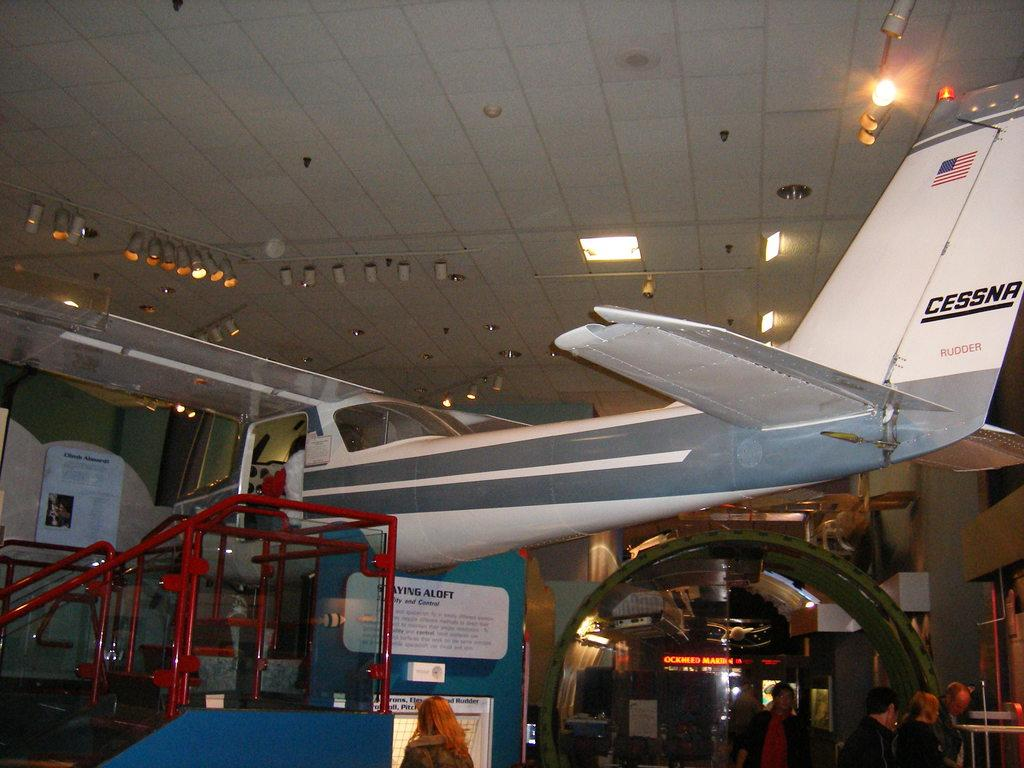<image>
Present a compact description of the photo's key features. A small Cessna aircraft displayed in an indoor museum. 